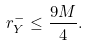<formula> <loc_0><loc_0><loc_500><loc_500>r ^ { - } _ { Y } \leq \frac { 9 M } 4 .</formula> 